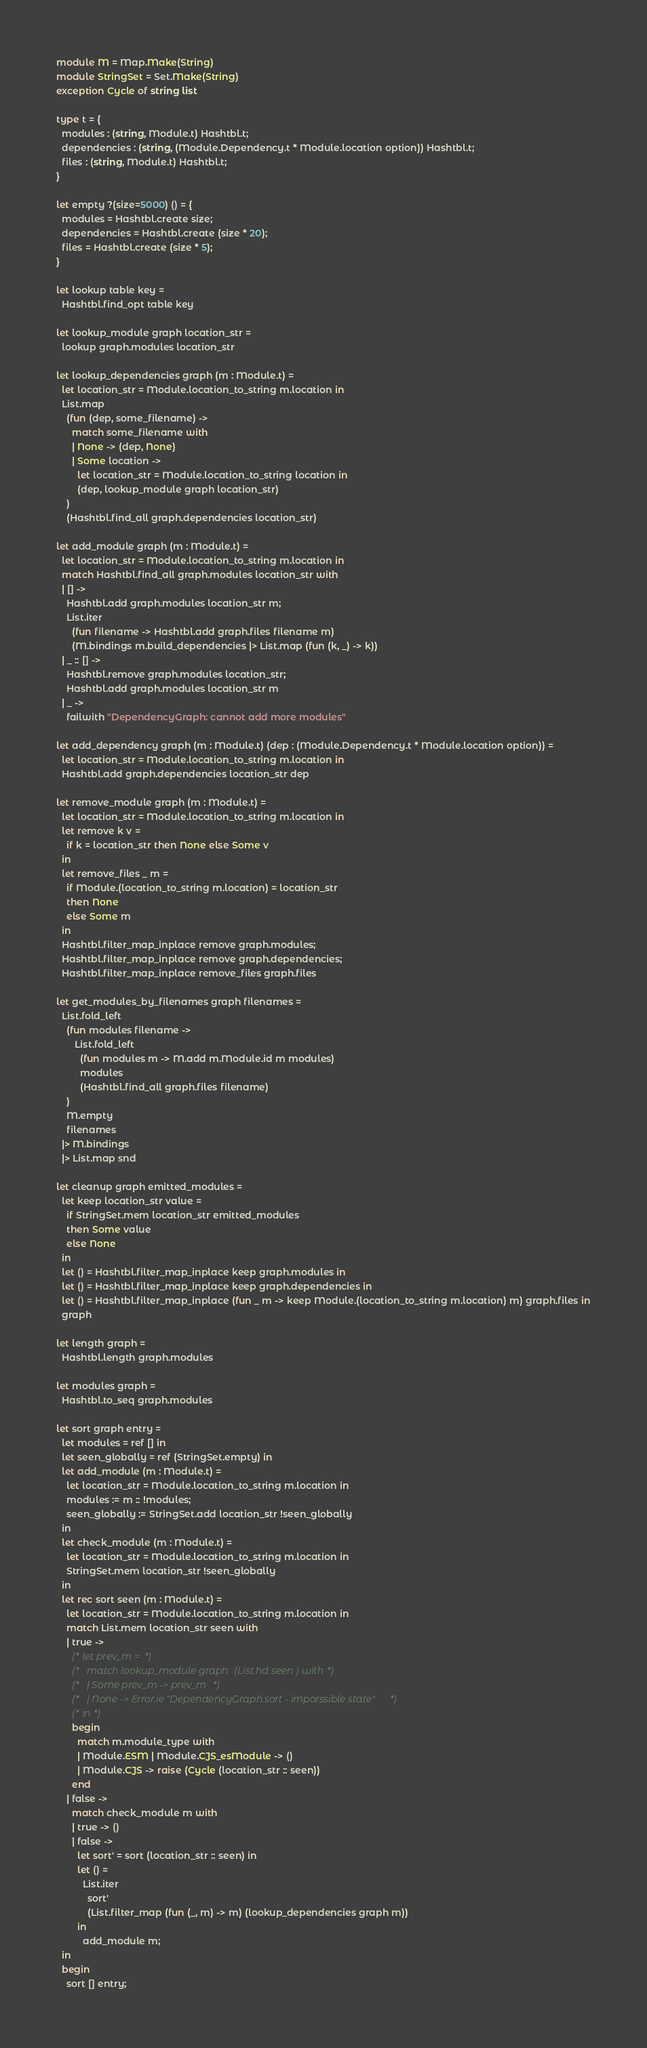<code> <loc_0><loc_0><loc_500><loc_500><_OCaml_>module M = Map.Make(String)
module StringSet = Set.Make(String)
exception Cycle of string list

type t = {
  modules : (string, Module.t) Hashtbl.t;
  dependencies : (string, (Module.Dependency.t * Module.location option)) Hashtbl.t;
  files : (string, Module.t) Hashtbl.t;
}

let empty ?(size=5000) () = {
  modules = Hashtbl.create size;
  dependencies = Hashtbl.create (size * 20);
  files = Hashtbl.create (size * 5);
}

let lookup table key =
  Hashtbl.find_opt table key

let lookup_module graph location_str =
  lookup graph.modules location_str

let lookup_dependencies graph (m : Module.t) =
  let location_str = Module.location_to_string m.location in
  List.map
    (fun (dep, some_filename) ->
      match some_filename with
      | None -> (dep, None)
      | Some location ->
        let location_str = Module.location_to_string location in
        (dep, lookup_module graph location_str)
    )
    (Hashtbl.find_all graph.dependencies location_str)

let add_module graph (m : Module.t) =
  let location_str = Module.location_to_string m.location in
  match Hashtbl.find_all graph.modules location_str with
  | [] ->
    Hashtbl.add graph.modules location_str m;
    List.iter
      (fun filename -> Hashtbl.add graph.files filename m)
      (M.bindings m.build_dependencies |> List.map (fun (k, _) -> k))
  | _ :: [] ->
    Hashtbl.remove graph.modules location_str;
    Hashtbl.add graph.modules location_str m
  | _ ->
    failwith "DependencyGraph: cannot add more modules"

let add_dependency graph (m : Module.t) (dep : (Module.Dependency.t * Module.location option)) =
  let location_str = Module.location_to_string m.location in
  Hashtbl.add graph.dependencies location_str dep

let remove_module graph (m : Module.t) =
  let location_str = Module.location_to_string m.location in
  let remove k v =
    if k = location_str then None else Some v
  in
  let remove_files _ m =
    if Module.(location_to_string m.location) = location_str
    then None
    else Some m
  in
  Hashtbl.filter_map_inplace remove graph.modules;
  Hashtbl.filter_map_inplace remove graph.dependencies;
  Hashtbl.filter_map_inplace remove_files graph.files

let get_modules_by_filenames graph filenames =
  List.fold_left
    (fun modules filename ->
       List.fold_left
         (fun modules m -> M.add m.Module.id m modules)
         modules
         (Hashtbl.find_all graph.files filename)
    )
    M.empty
    filenames
  |> M.bindings
  |> List.map snd

let cleanup graph emitted_modules =
  let keep location_str value =
    if StringSet.mem location_str emitted_modules
    then Some value
    else None
  in
  let () = Hashtbl.filter_map_inplace keep graph.modules in
  let () = Hashtbl.filter_map_inplace keep graph.dependencies in
  let () = Hashtbl.filter_map_inplace (fun _ m -> keep Module.(location_to_string m.location) m) graph.files in
  graph

let length graph =
  Hashtbl.length graph.modules

let modules graph =
  Hashtbl.to_seq graph.modules

let sort graph entry =
  let modules = ref [] in
  let seen_globally = ref (StringSet.empty) in
  let add_module (m : Module.t) =
    let location_str = Module.location_to_string m.location in
    modules := m :: !modules;
    seen_globally := StringSet.add location_str !seen_globally
  in
  let check_module (m : Module.t) =
    let location_str = Module.location_to_string m.location in
    StringSet.mem location_str !seen_globally
  in
  let rec sort seen (m : Module.t) =
    let location_str = Module.location_to_string m.location in
    match List.mem location_str seen with
    | true ->
      (* let prev_m = *)
      (*   match lookup_module graph (List.hd seen) with *)
      (*   | Some prev_m -> prev_m *)
      (*   | None -> Error.ie "DependencyGraph.sort - imporssible state" *)
      (* in *)
      begin
        match m.module_type with
        | Module.ESM | Module.CJS_esModule -> ()
        | Module.CJS -> raise (Cycle (location_str :: seen))
      end
    | false ->
      match check_module m with
      | true -> ()
      | false ->
        let sort' = sort (location_str :: seen) in
        let () =
          List.iter
            sort'
            (List.filter_map (fun (_, m) -> m) (lookup_dependencies graph m))
        in
          add_module m;
  in
  begin
    sort [] entry;</code> 